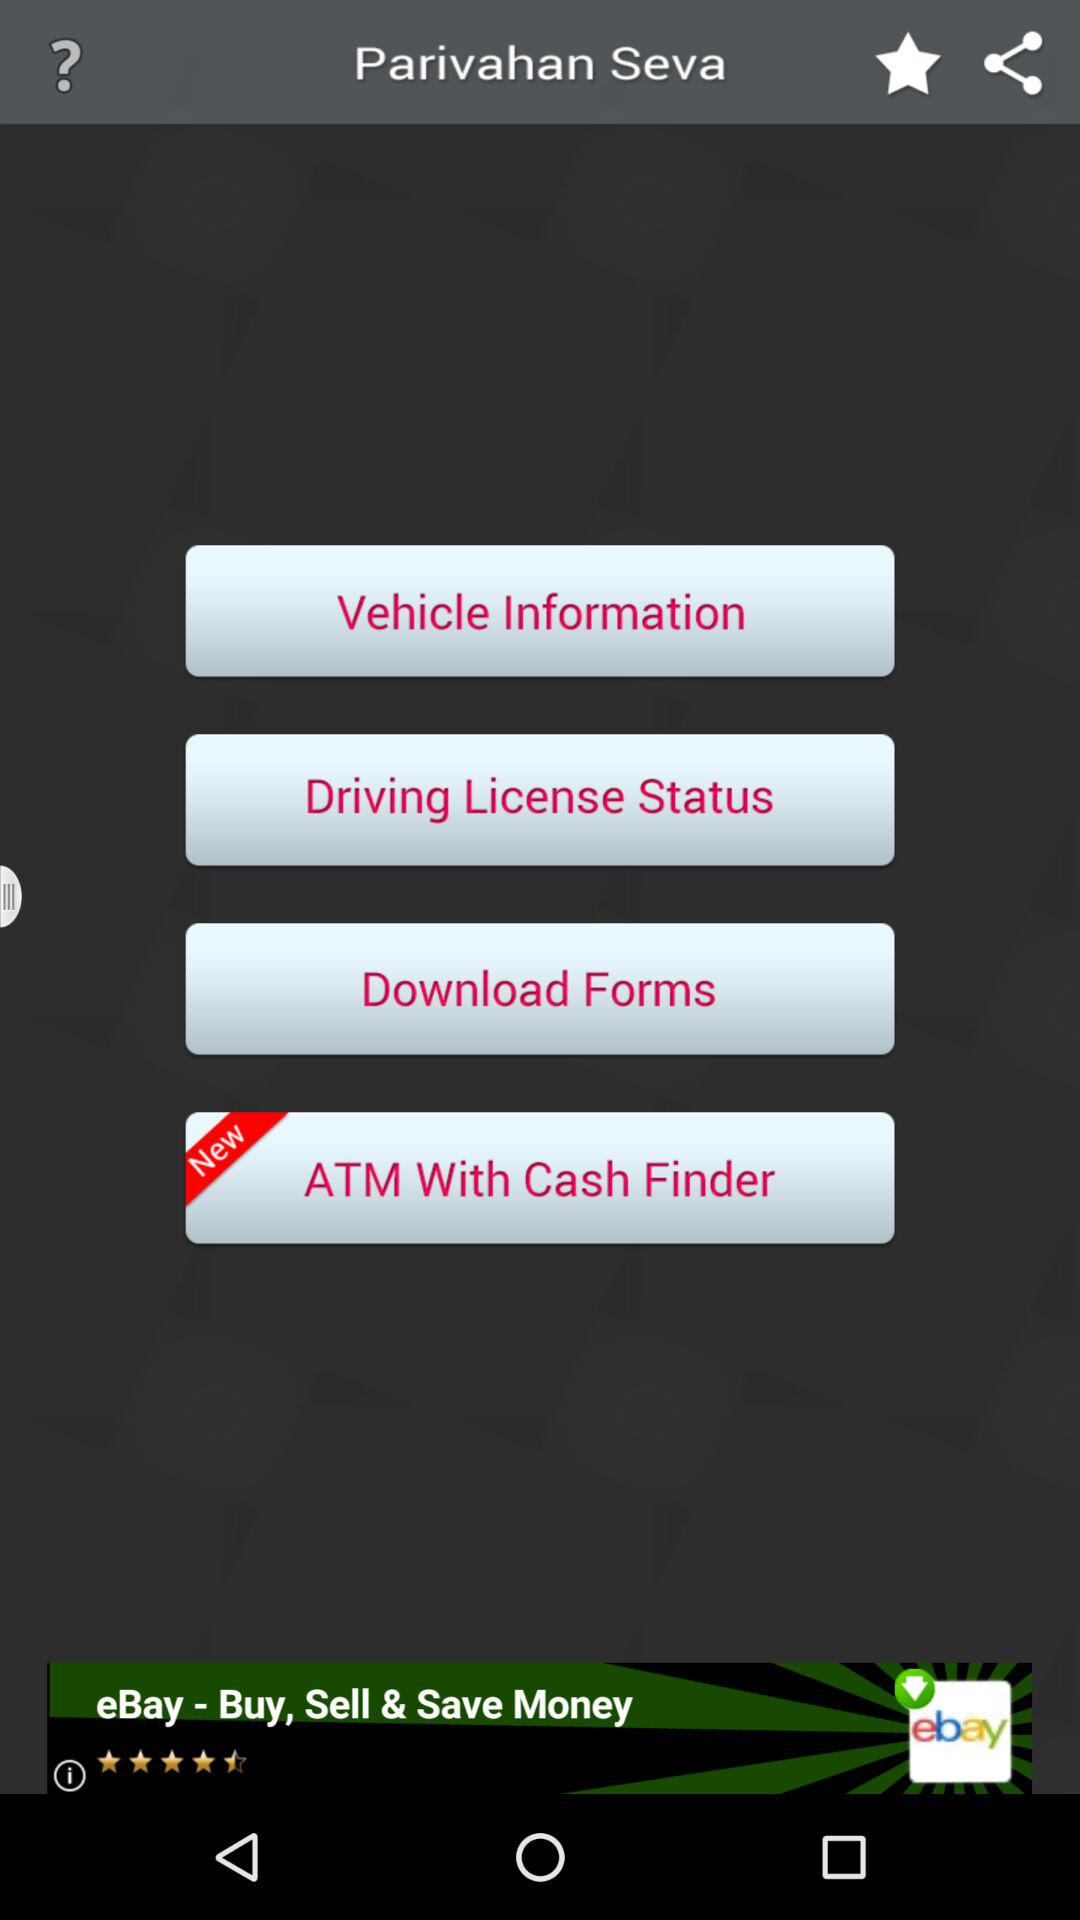Which option is the new one? The new option is "ATM With Cash Finder". 